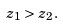<formula> <loc_0><loc_0><loc_500><loc_500>z _ { 1 } > z _ { 2 } .</formula> 